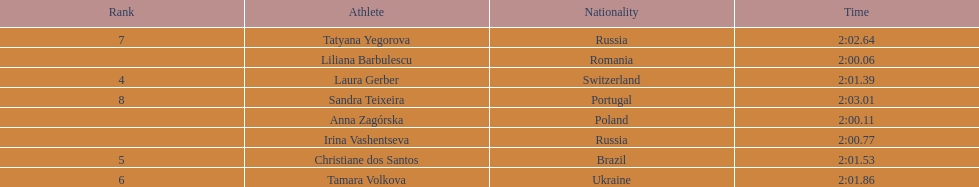How many runners finished with their time below 2:01? 3. 